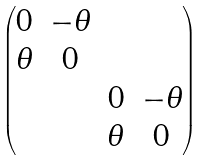Convert formula to latex. <formula><loc_0><loc_0><loc_500><loc_500>\begin{pmatrix} 0 & - \theta & & \\ \theta & 0 & & \\ & & 0 & - \theta \\ & & \theta & 0 \end{pmatrix}</formula> 